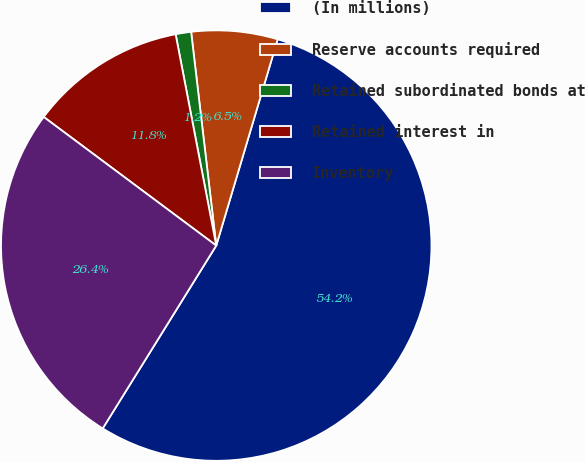<chart> <loc_0><loc_0><loc_500><loc_500><pie_chart><fcel>(In millions)<fcel>Reserve accounts required<fcel>Retained subordinated bonds at<fcel>Retained interest in<fcel>Inventory<nl><fcel>54.23%<fcel>6.47%<fcel>1.16%<fcel>11.78%<fcel>26.35%<nl></chart> 